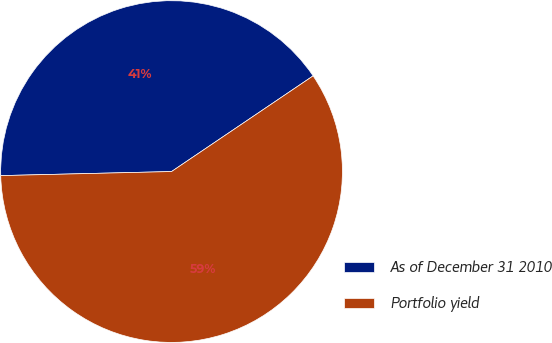<chart> <loc_0><loc_0><loc_500><loc_500><pie_chart><fcel>As of December 31 2010<fcel>Portfolio yield<nl><fcel>40.92%<fcel>59.08%<nl></chart> 